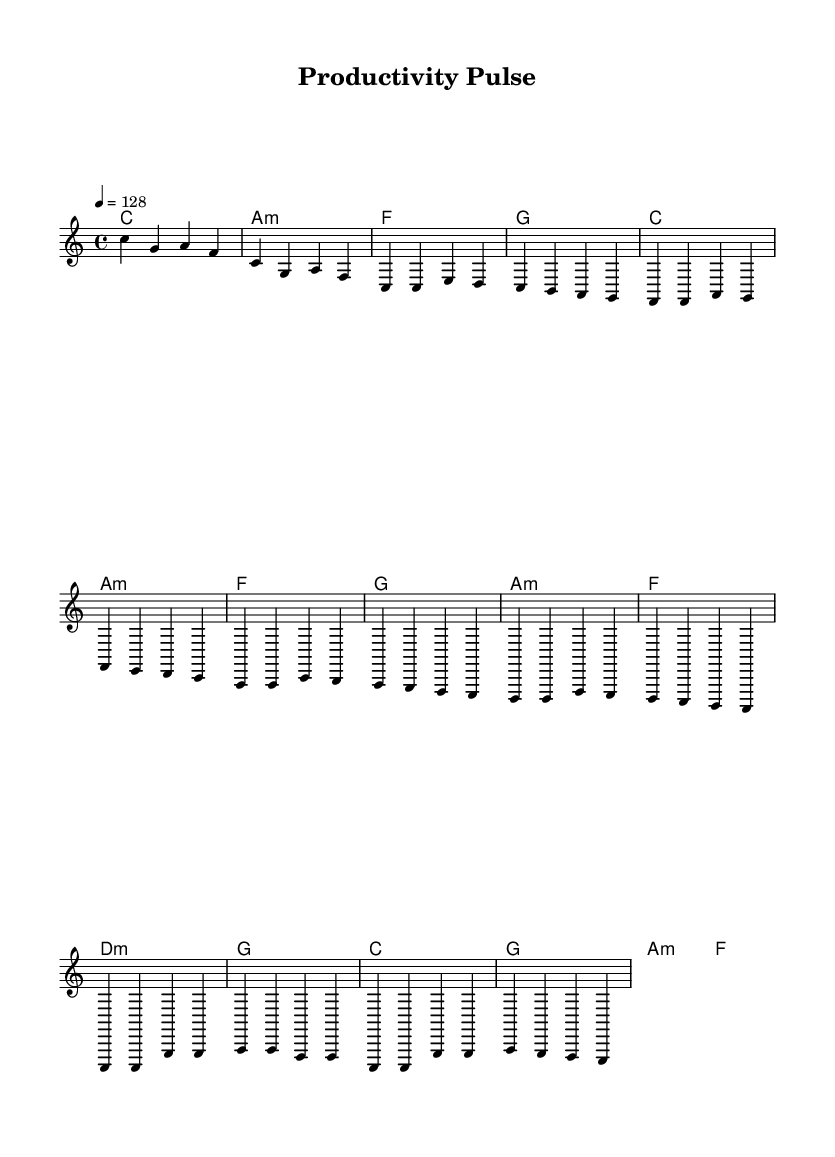What is the key signature of this music? The key signature is C major, which is identified by the absence of any sharps or flats in the sheet music.
Answer: C major What is the time signature of this music? The time signature is 4/4, which indicates that there are four beats in each measure and the quarter note gets one beat. This is visible in the notational part of the sheet music under the global settings.
Answer: 4/4 What is the tempo marking of this music? The tempo marking is 128, indicating that the quarter note should be played at a speed of 128 beats per minute. This is specified in the global section of the sheet music.
Answer: 128 What type of chords are used in the pre-chorus section? The pre-chorus contains minor chords identified as a minor and d minor chords, indicated by the presence of "a:m" and "d:m" in the harmonies. This suggests a shift to a more melancholic mood before the upbeat chorus.
Answer: Minor Which section uses repeated melodies? The chorus section features repeated melody patterns as the same sequence appears twice (c c g' g), emphasizing a catchy hook typical in pop music. This can be observed in the melody line where c c g' g is repeated.
Answer: Chorus 